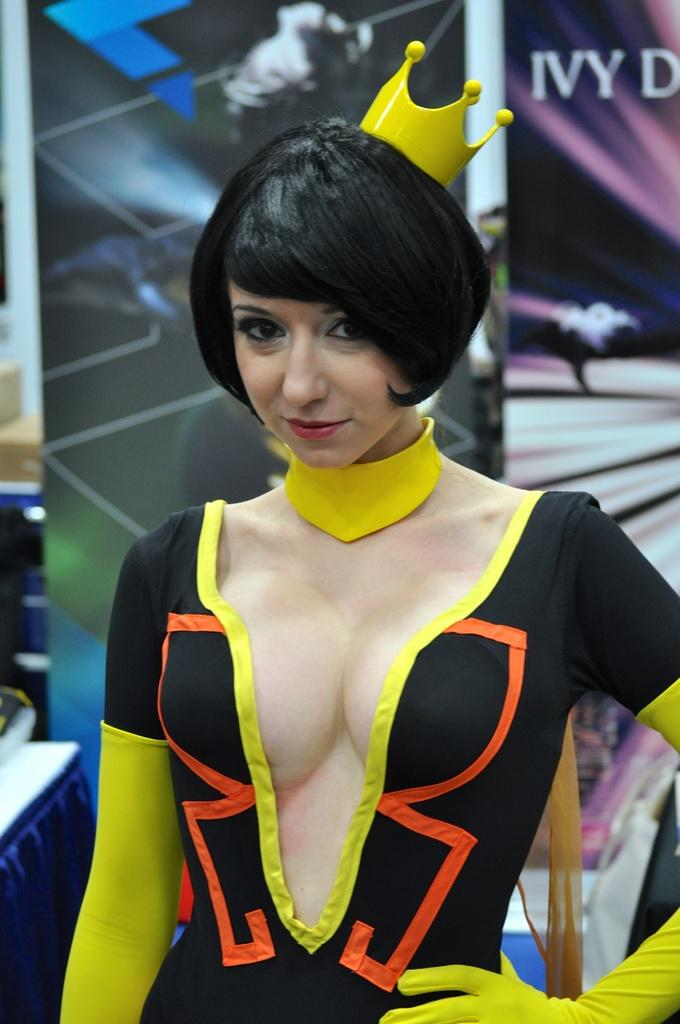Provide a one-sentence caption for the provided image. A costumed woman stand in front of a banner that partially reads "IVY". 